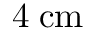Convert formula to latex. <formula><loc_0><loc_0><loc_500><loc_500>4 \, { c m }</formula> 